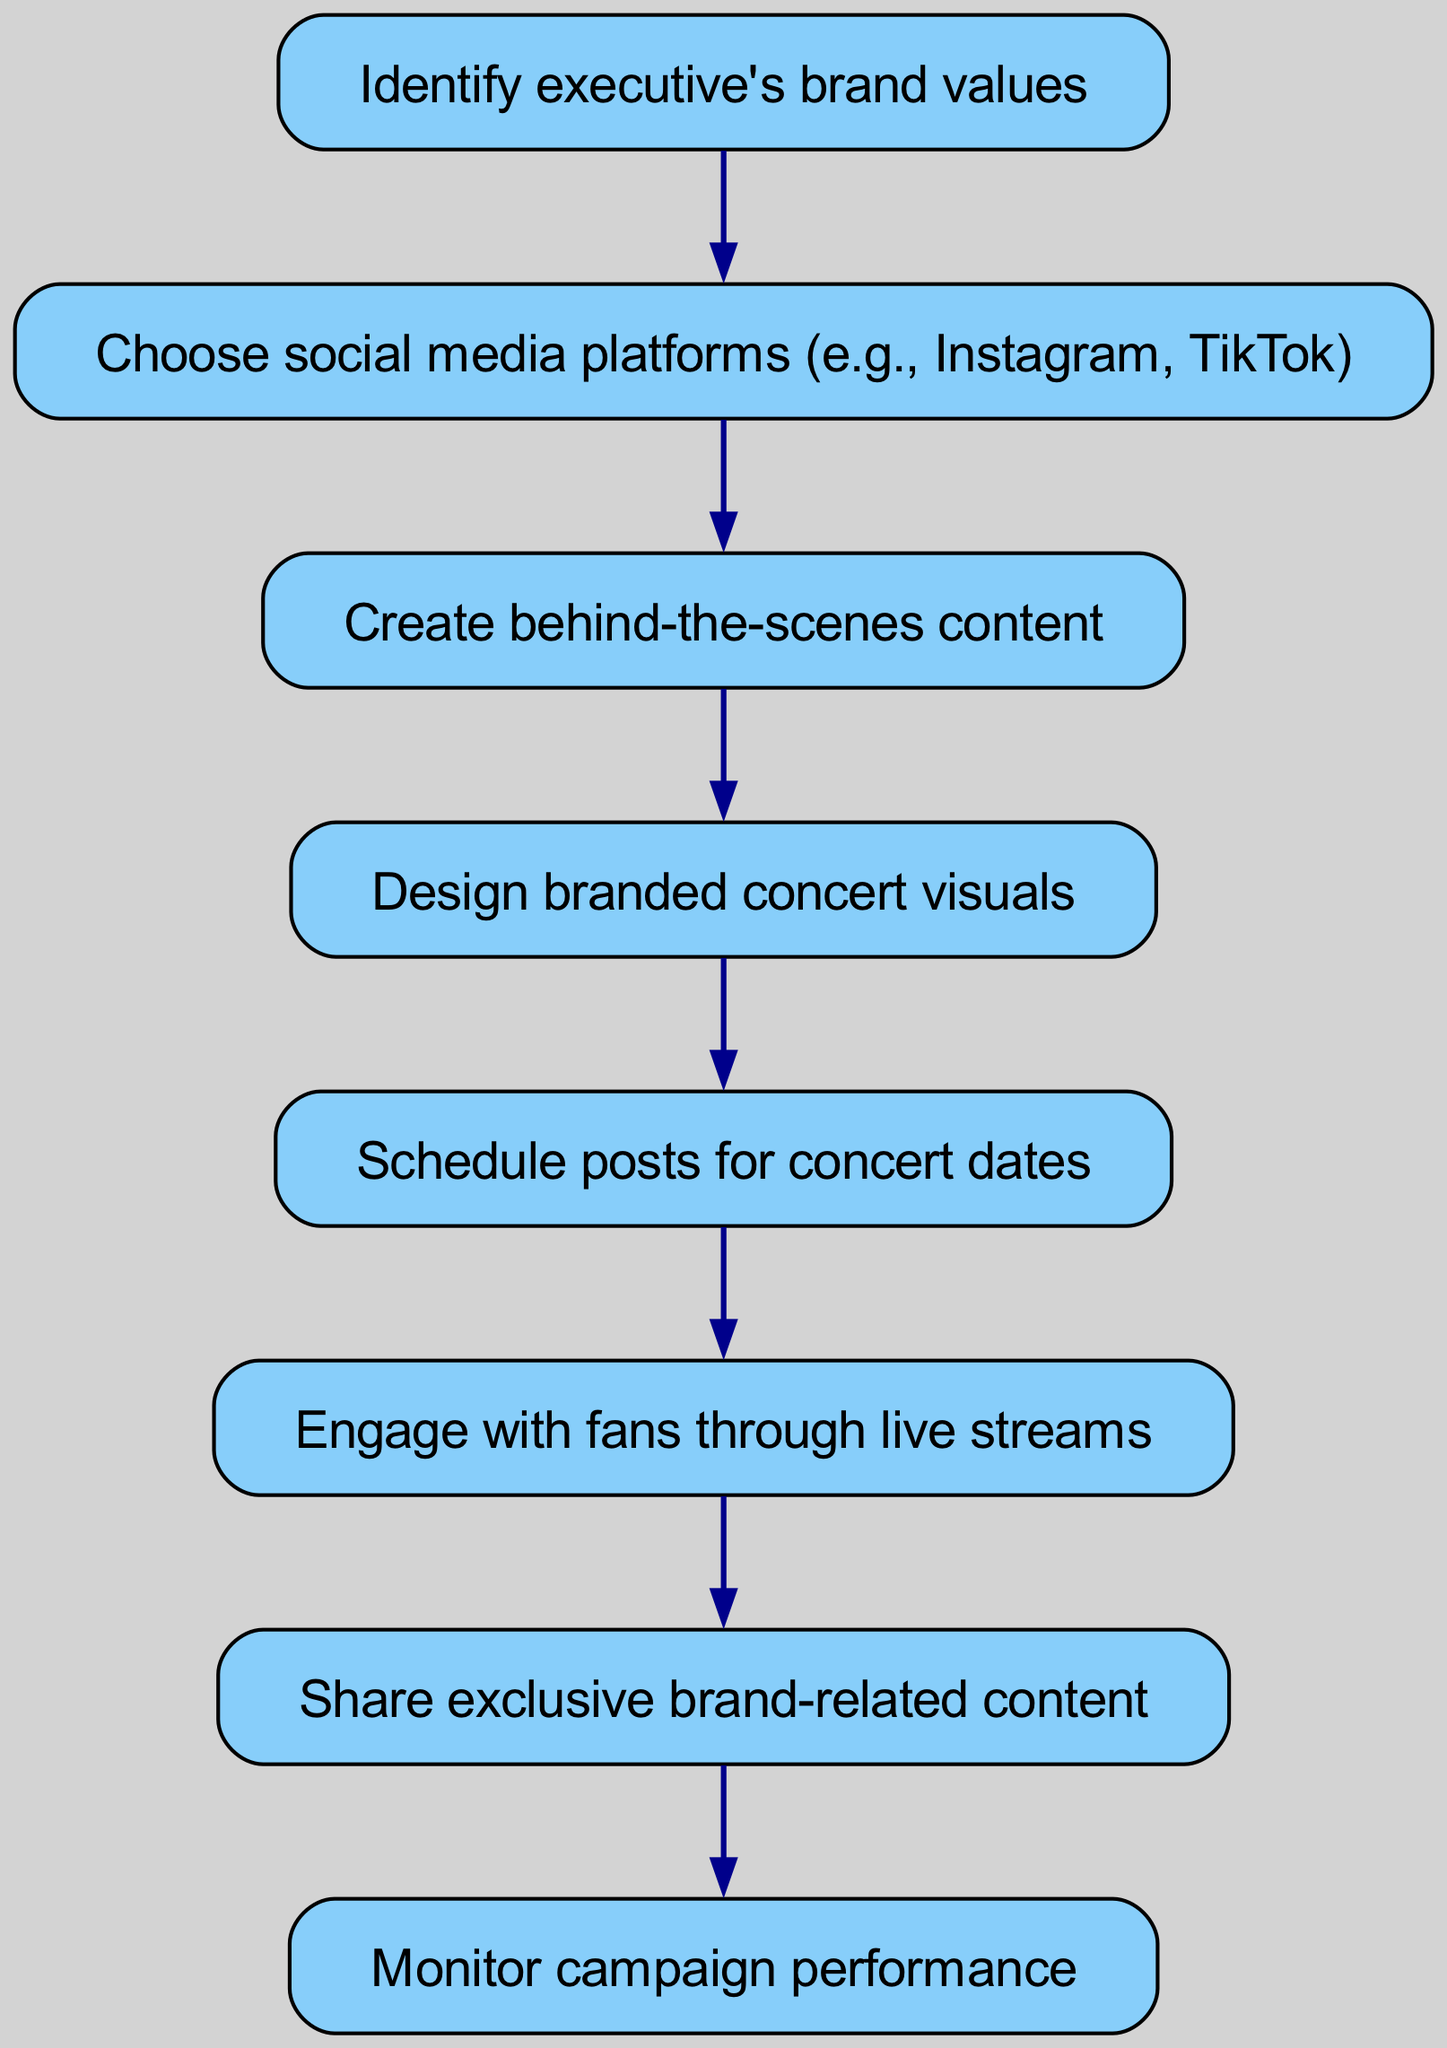What is the first step in the social media campaign? The diagram indicates that the first step in the social media campaign is to "Identify executive's brand values", as it is the starting node before any other actions are taken.
Answer: Identify executive's brand values How many total steps are there in the diagram? By counting each individual step from the starting to the ending node, there are a total of eight steps outlined in the flowchart.
Answer: Eight Which step comes after designing branded concert visuals? The diagram shows that the step following "Design branded concert visuals" is "Schedule posts for concert dates", as indicated by the direct flow from one node to the next.
Answer: Schedule posts for concert dates What is the last step in the flow of the campaign? According to the diagram, the last step in the flow of the social media campaign is "Monitor campaign performance", which is the final node and does not lead to any other steps.
Answer: Monitor campaign performance Which two steps directly involve engaging with fans? The steps that directly involve engaging with fans are "Engage with fans through live streams" and "Share exclusive brand-related content", as both of these steps focus on fan interaction and communication.
Answer: Engage with fans through live streams and Share exclusive brand-related content 